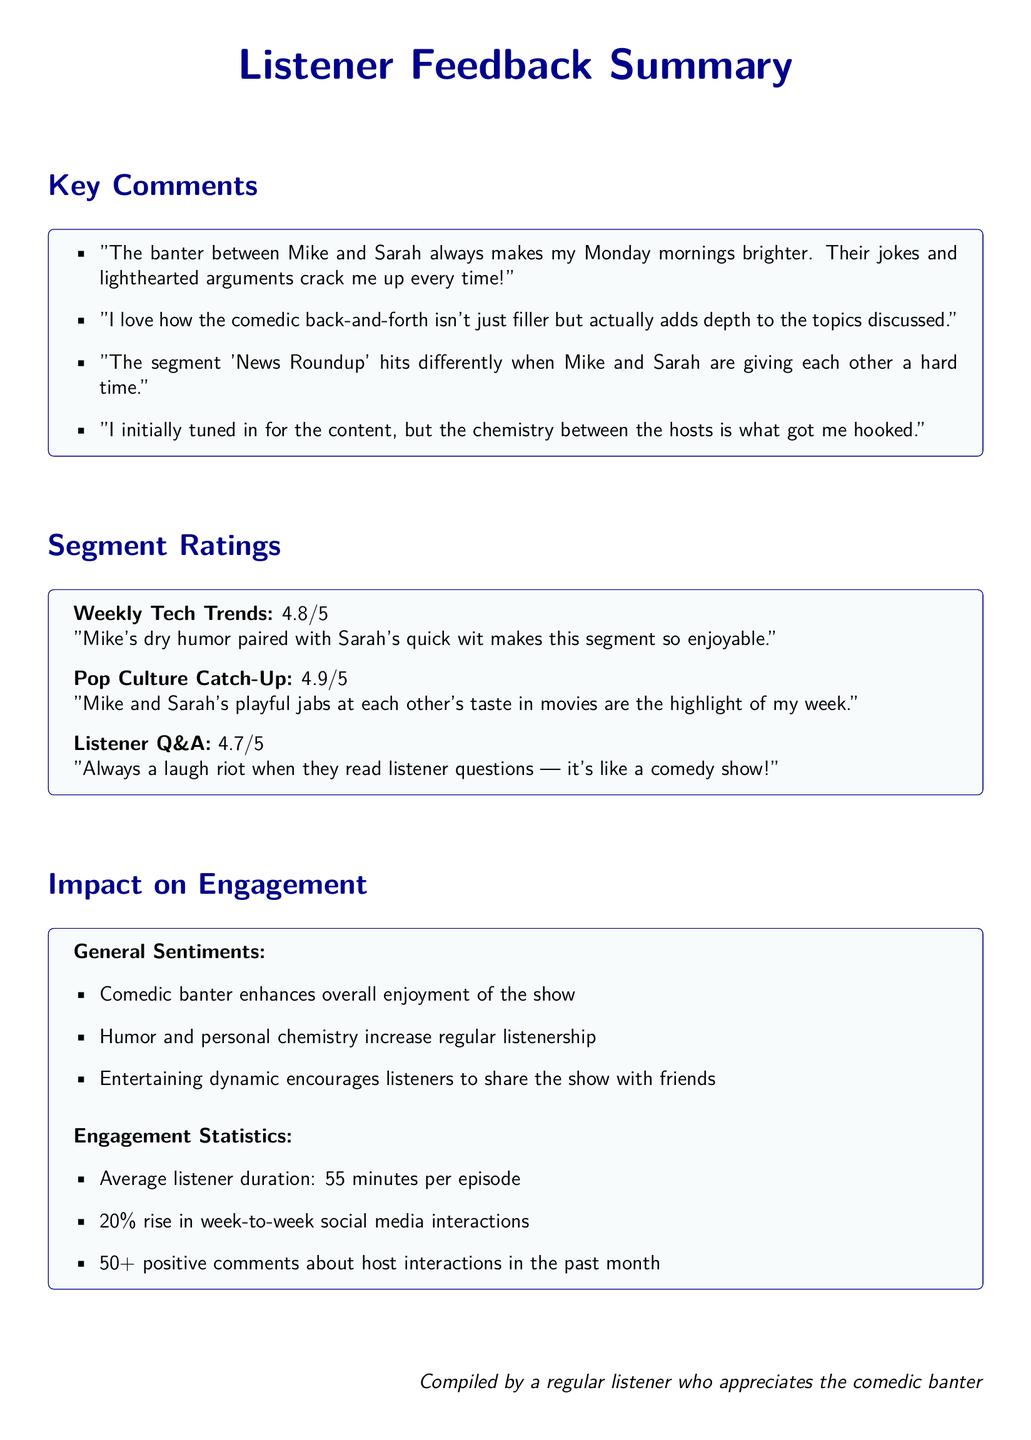what is the rating for Weekly Tech Trends? The rating for Weekly Tech Trends is provided in the Segment Ratings section of the document, which states it is 4.8 out of 5.
Answer: 4.8/5 who are the hosts of the show? The hosts of the show are mentioned in the Key Comments section as Mike and Sarah.
Answer: Mike and Sarah what sentiment is expressed about the impact of comedic banter? The General Sentiments section states that comedic banter enhances the overall enjoyment of the show.
Answer: Enhances overall enjoyment how much has social media interaction increased week-to-week? The document indicates a 20 percent rise in week-to-week social media interactions under Engagement Statistics.
Answer: 20% what is the average listener duration per episode? The average listener duration is noted in the Engagement Statistics section, which indicates it is 55 minutes.
Answer: 55 minutes what is the rating for Pop Culture Catch-Up? The rating for Pop Culture Catch-Up is provided in the Segment Ratings section and is 4.9 out of 5.
Answer: 4.9/5 how many positive comments about host interactions were recorded in the past month? The Engagement Statistics section mentions there are over 50 positive comments about host interactions in the past month.
Answer: 50+ what type of segment is described as a "laugh riot"? The segment described as a "laugh riot" is mentioned in the Segment Ratings section referring to Listener Q&A.
Answer: Listener Q&A what is emphasized as adding depth to the discussions? The comments note that the comedic back-and-forth between the hosts adds depth to the topics discussed.
Answer: Adds depth to the topics discussed 